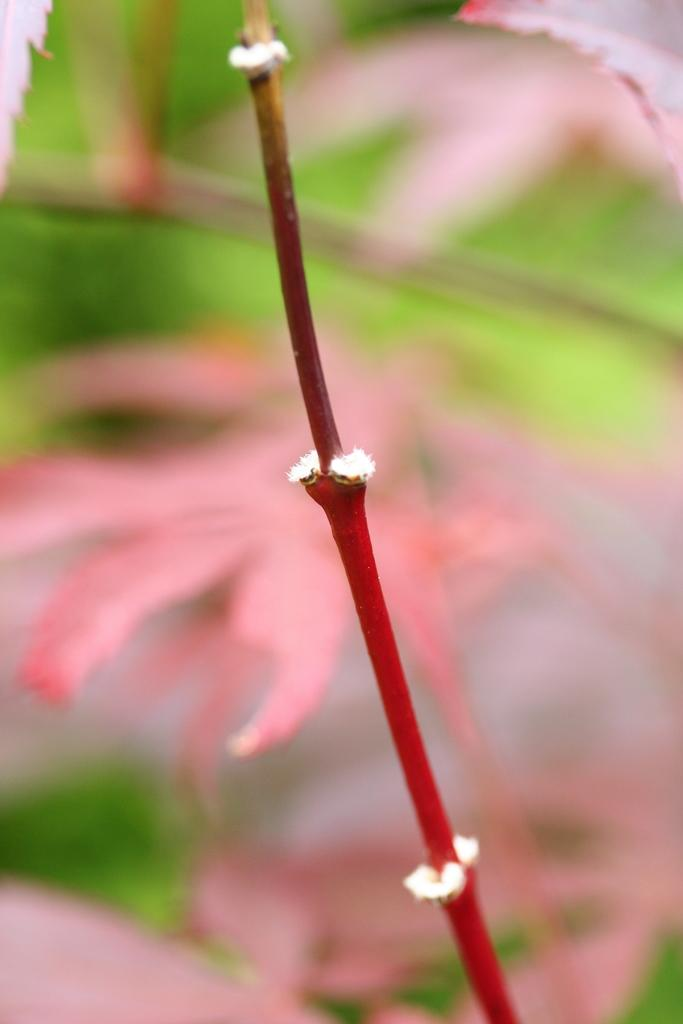What is the main subject of the image? The main subject of the image is a stem. Can you describe the background of the image? The background of the image is blurred. What type of toothbrush is your brother using on vacation in the image? There is no toothbrush, brother, or vacation mentioned in the image. The image only features a stem with a blurred background. 